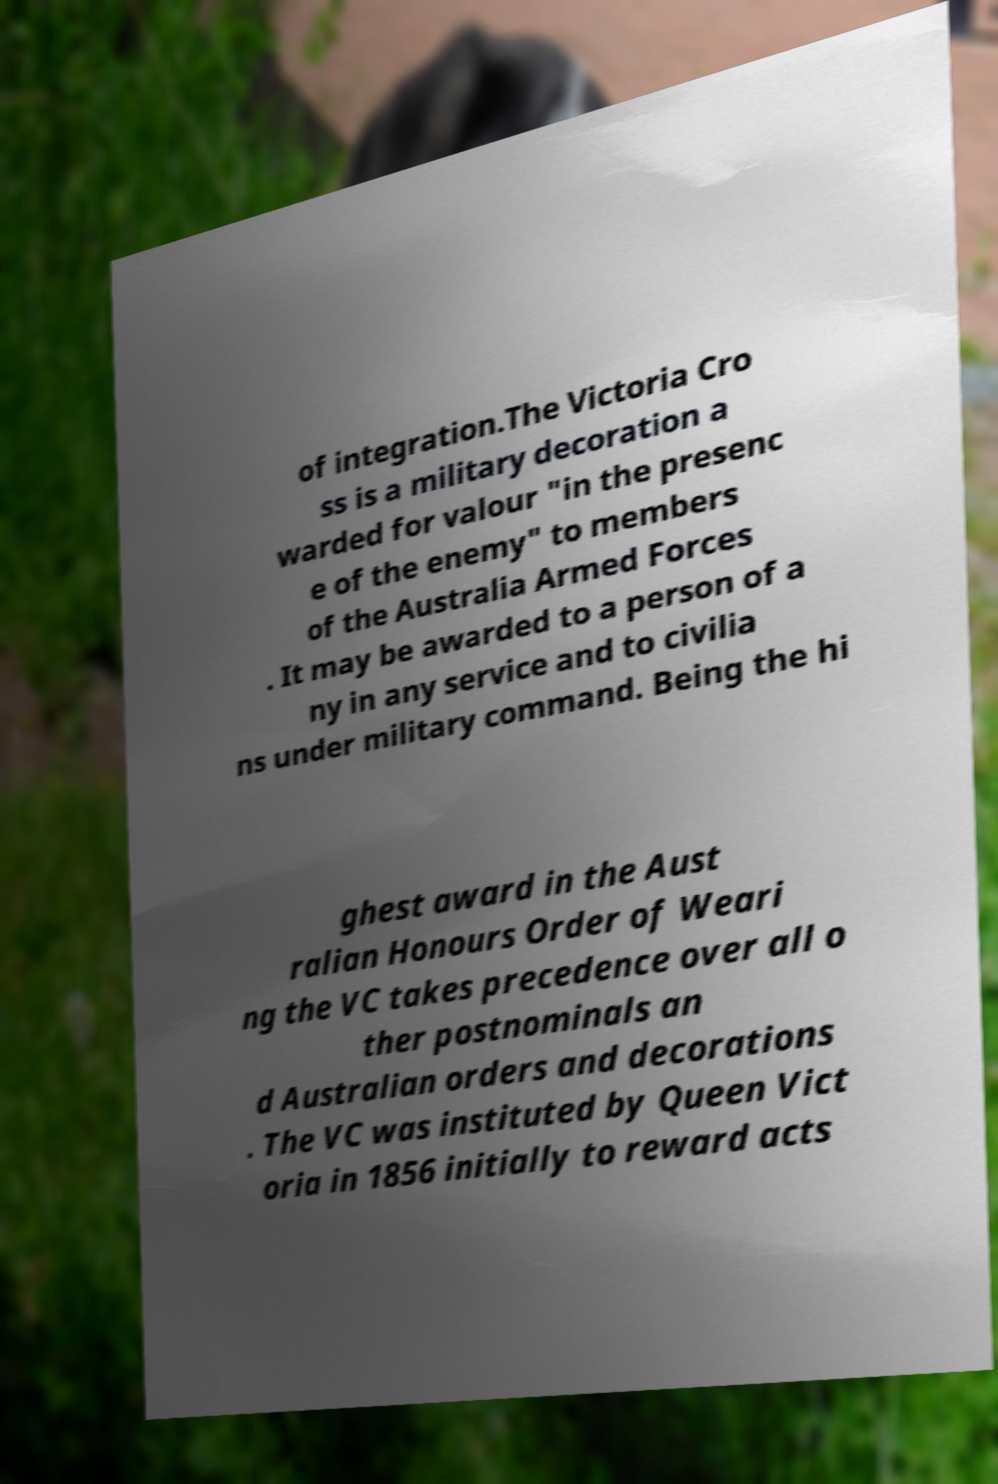Can you read and provide the text displayed in the image?This photo seems to have some interesting text. Can you extract and type it out for me? of integration.The Victoria Cro ss is a military decoration a warded for valour "in the presenc e of the enemy" to members of the Australia Armed Forces . It may be awarded to a person of a ny in any service and to civilia ns under military command. Being the hi ghest award in the Aust ralian Honours Order of Weari ng the VC takes precedence over all o ther postnominals an d Australian orders and decorations . The VC was instituted by Queen Vict oria in 1856 initially to reward acts 